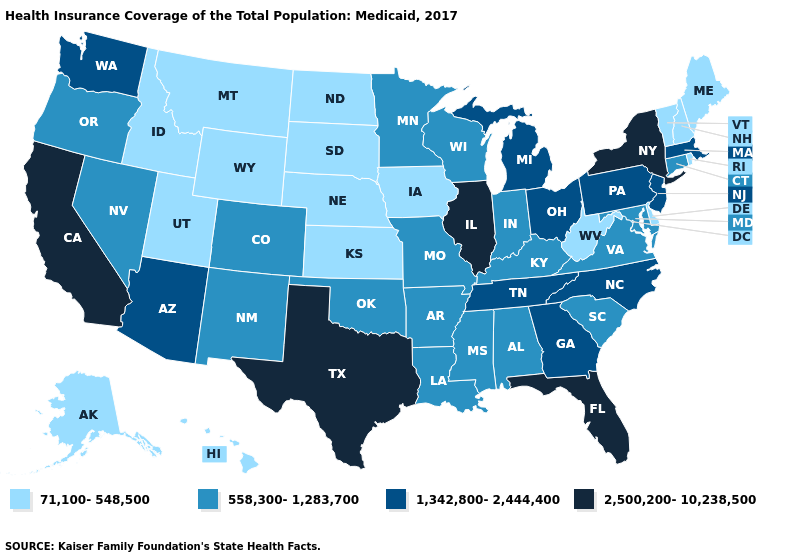What is the value of Maryland?
Be succinct. 558,300-1,283,700. Does Texas have the lowest value in the South?
Answer briefly. No. Among the states that border New Mexico , does Texas have the lowest value?
Give a very brief answer. No. Name the states that have a value in the range 71,100-548,500?
Write a very short answer. Alaska, Delaware, Hawaii, Idaho, Iowa, Kansas, Maine, Montana, Nebraska, New Hampshire, North Dakota, Rhode Island, South Dakota, Utah, Vermont, West Virginia, Wyoming. What is the highest value in states that border Idaho?
Concise answer only. 1,342,800-2,444,400. What is the highest value in the MidWest ?
Quick response, please. 2,500,200-10,238,500. Which states have the highest value in the USA?
Be succinct. California, Florida, Illinois, New York, Texas. Name the states that have a value in the range 2,500,200-10,238,500?
Answer briefly. California, Florida, Illinois, New York, Texas. Name the states that have a value in the range 2,500,200-10,238,500?
Be succinct. California, Florida, Illinois, New York, Texas. Which states have the highest value in the USA?
Write a very short answer. California, Florida, Illinois, New York, Texas. Does California have the highest value in the USA?
Short answer required. Yes. Which states hav the highest value in the MidWest?
Keep it brief. Illinois. What is the value of New Hampshire?
Quick response, please. 71,100-548,500. What is the lowest value in states that border Texas?
Concise answer only. 558,300-1,283,700. Does Connecticut have a lower value than New York?
Be succinct. Yes. 